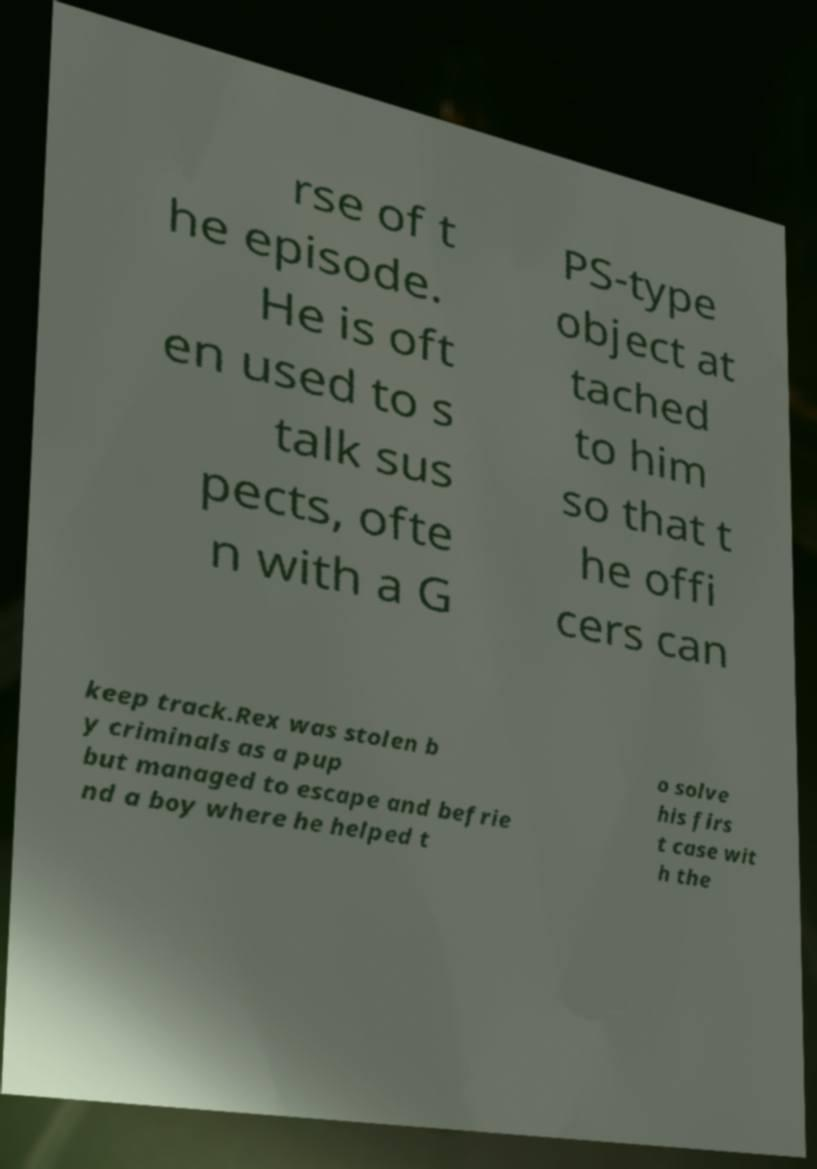Could you assist in decoding the text presented in this image and type it out clearly? rse of t he episode. He is oft en used to s talk sus pects, ofte n with a G PS-type object at tached to him so that t he offi cers can keep track.Rex was stolen b y criminals as a pup but managed to escape and befrie nd a boy where he helped t o solve his firs t case wit h the 